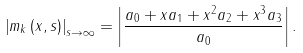<formula> <loc_0><loc_0><loc_500><loc_500>\left | m _ { k } \left ( x , s \right ) \right | _ { s \rightarrow \infty } = \left | \frac { a _ { 0 } + x a _ { 1 } + x ^ { 2 } a _ { 2 } + x ^ { 3 } a _ { 3 } } { a _ { 0 } } \right | .</formula> 